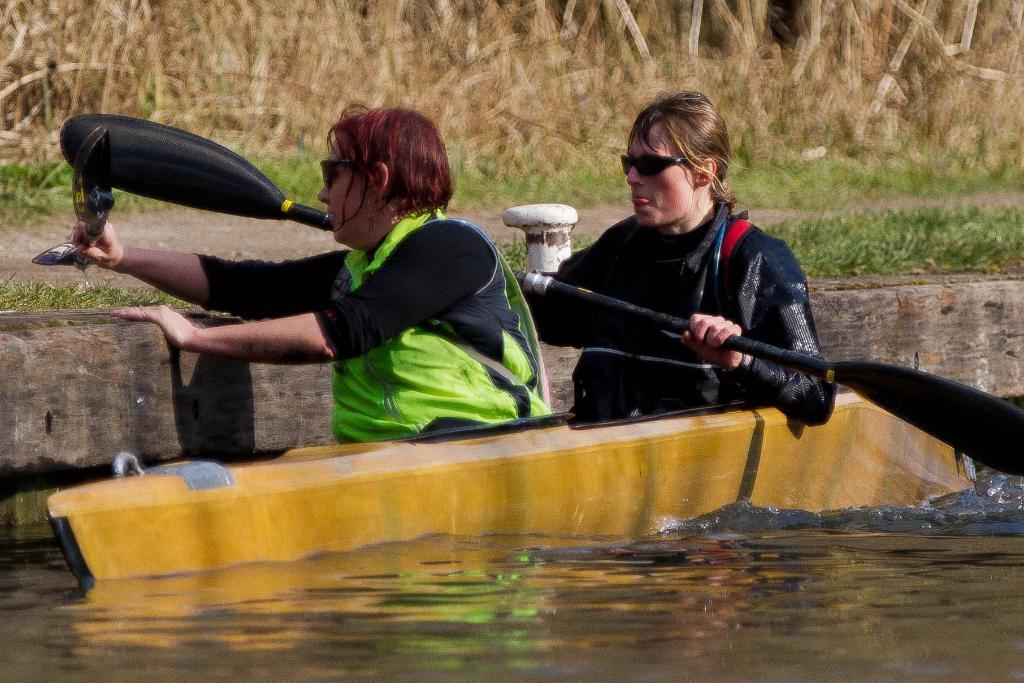Please provide a concise description of this image. In this picture I can see there are two people sitting in a boat, in the backdrop there is grass. 